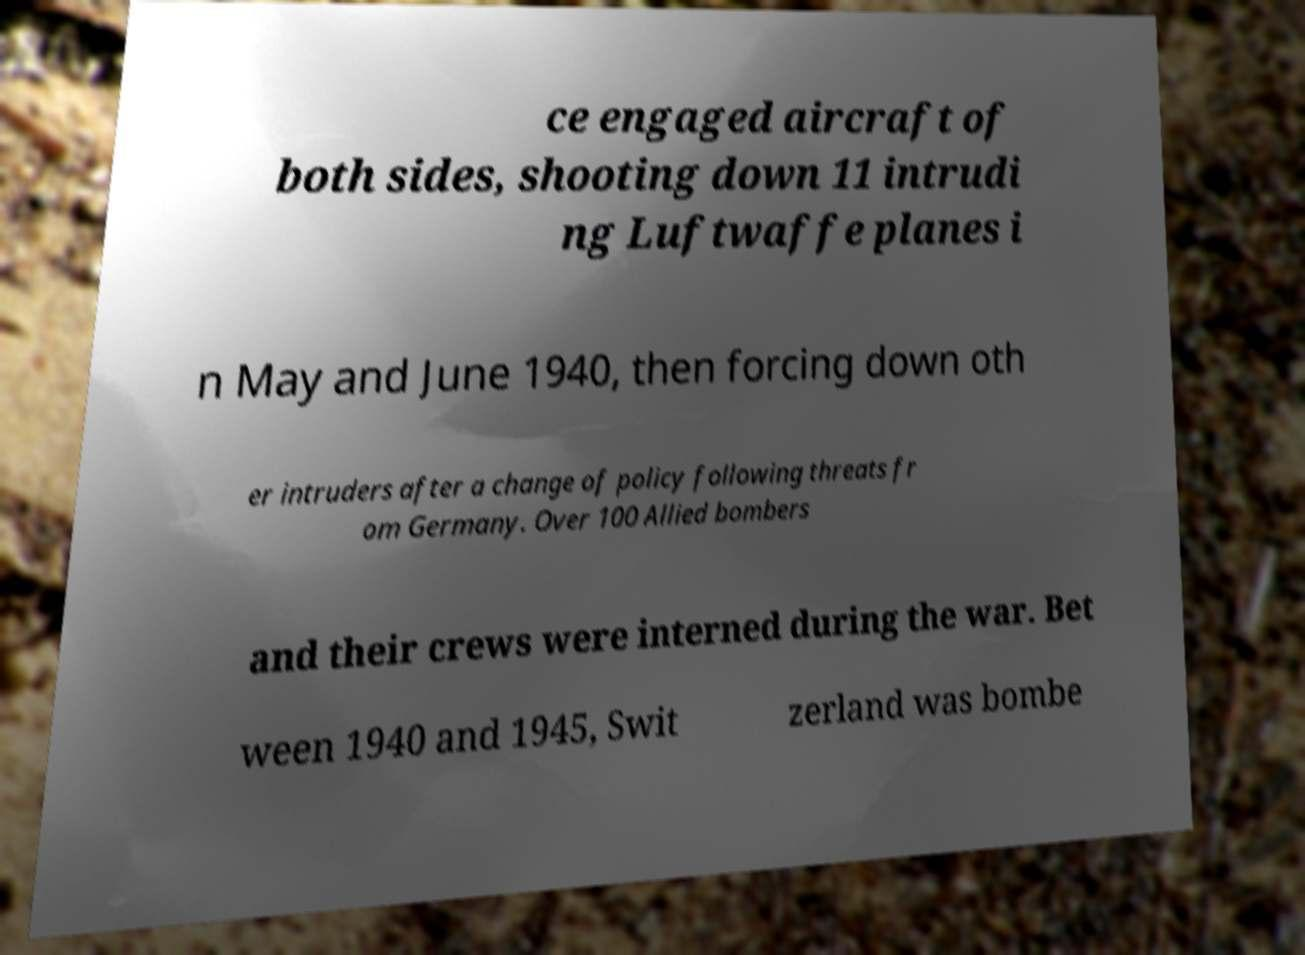Can you accurately transcribe the text from the provided image for me? ce engaged aircraft of both sides, shooting down 11 intrudi ng Luftwaffe planes i n May and June 1940, then forcing down oth er intruders after a change of policy following threats fr om Germany. Over 100 Allied bombers and their crews were interned during the war. Bet ween 1940 and 1945, Swit zerland was bombe 